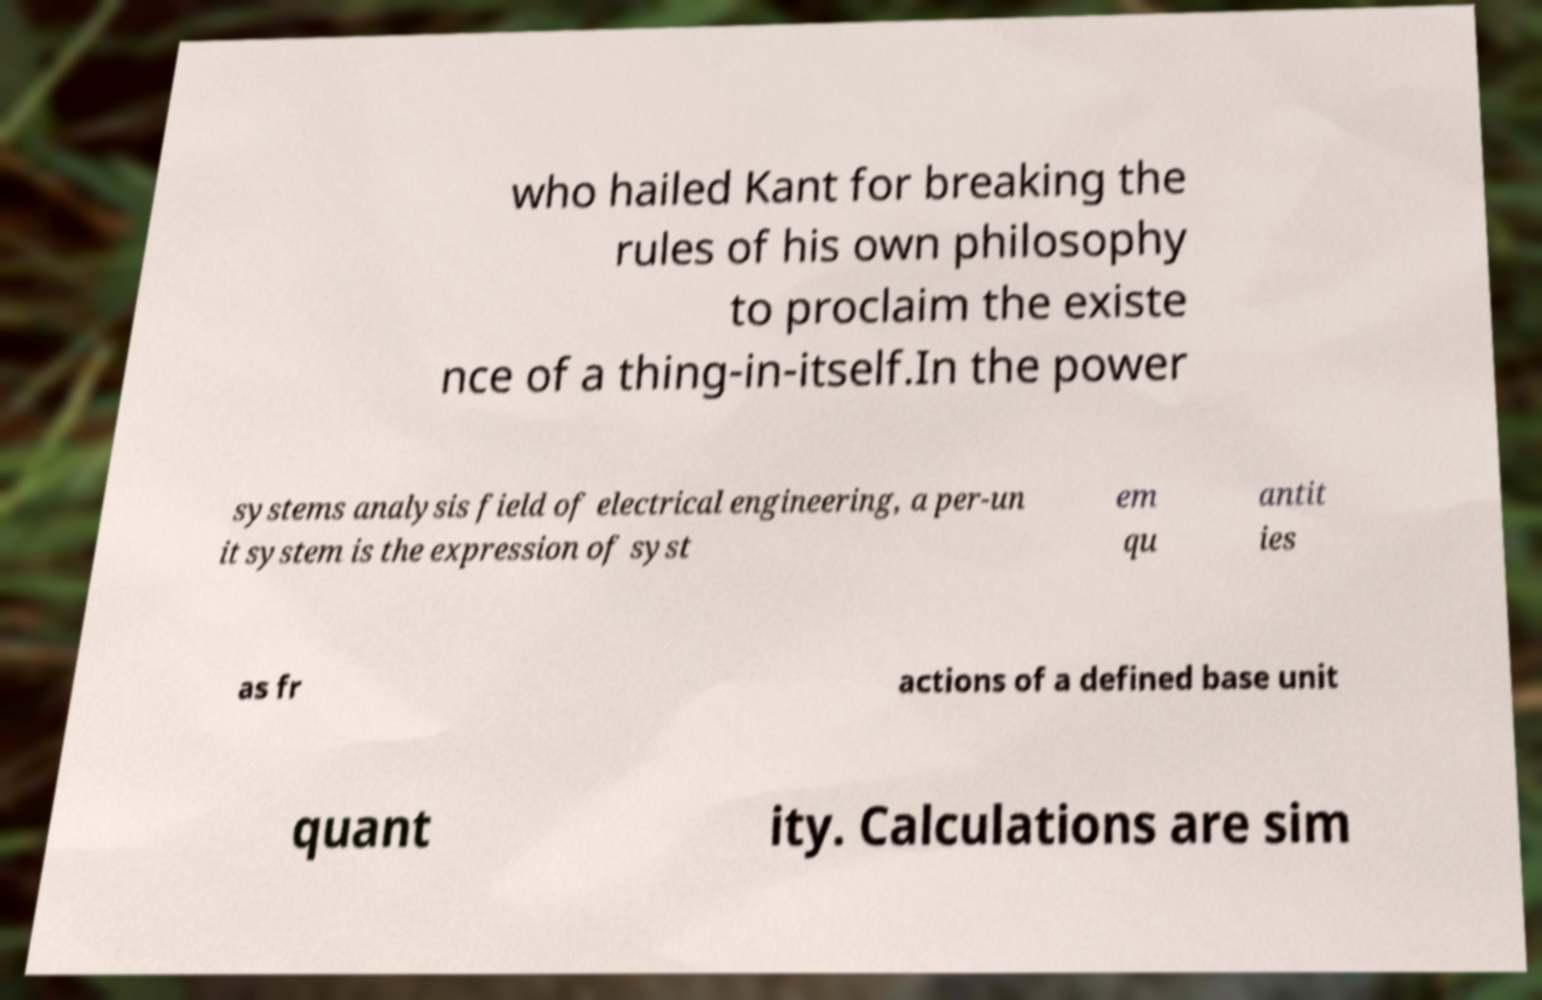For documentation purposes, I need the text within this image transcribed. Could you provide that? who hailed Kant for breaking the rules of his own philosophy to proclaim the existe nce of a thing-in-itself.In the power systems analysis field of electrical engineering, a per-un it system is the expression of syst em qu antit ies as fr actions of a defined base unit quant ity. Calculations are sim 